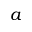Convert formula to latex. <formula><loc_0><loc_0><loc_500><loc_500>a</formula> 